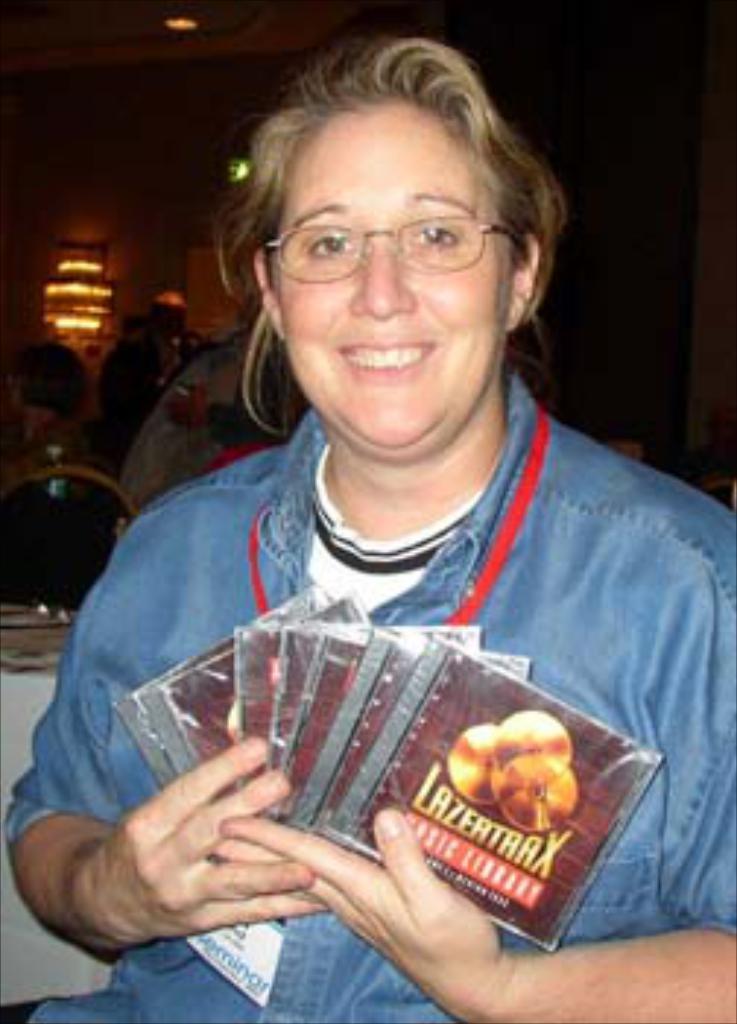Describe this image in one or two sentences. In this picture there is a lady in the center of the image,, by holding CD'S in her hands, there are other people in the background area of the image, there are lights at the top side of the image. 